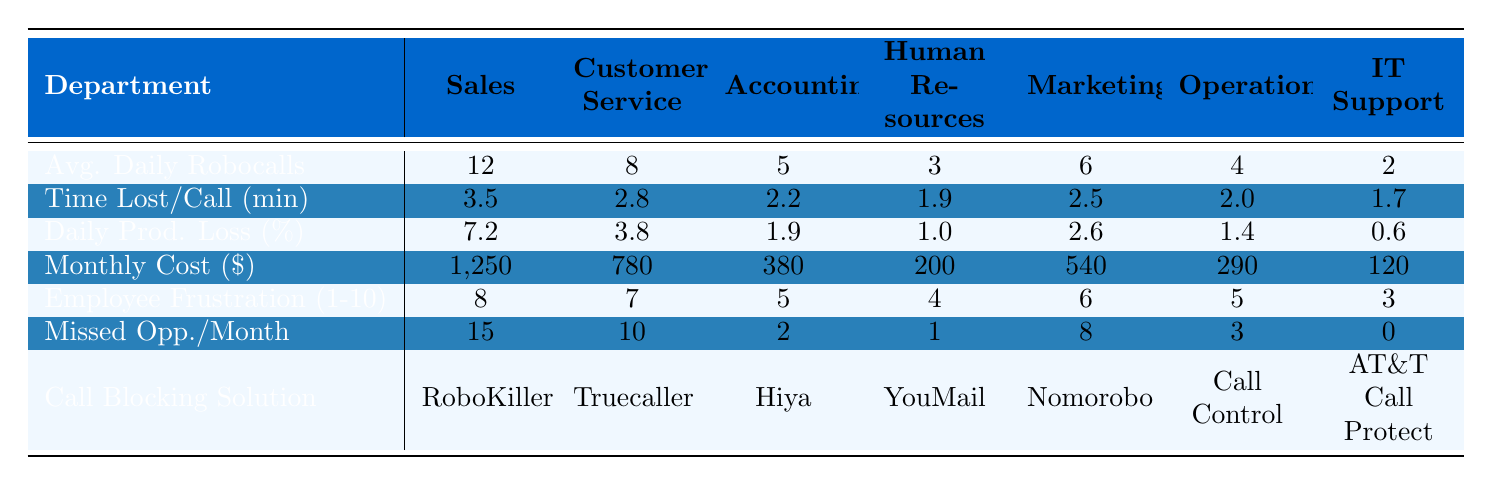What department experiences the highest average daily robocalls? Looking at the "Avg. Daily Robocalls" row, Sales department has the highest value of 12.
Answer: Sales What is the total daily productivity loss percentage for Sales and Customer Service? For Sales, the loss is 7.2% and for Customer Service, it's 3.8%. Adding these together gives 7.2 + 3.8 = 11%.
Answer: 11% Which department has the lowest employee frustration level? The "Employee Frustration (1-10)" row shows that IT Support has the lowest score of 3.
Answer: IT Support How much money is lost monthly due to productivity loss in the Accounting department? The "Monthly Cost" for Accounting is given as $380.
Answer: 380 Does Marketing have more missed opportunities per month than Human Resources? Marketing (8 missed opportunities) does indeed exceed Human Resources (1 missed opportunity).
Answer: Yes What is the average time lost per robocall across all departments? Summing the "Time Lost/Call (min)" gives (3.5 + 2.8 + 2.2 + 1.9 + 2.5 + 2.0 + 1.7) = 16.6 minutes, divided by 7 departments gives, on average, about 2.37 minutes.
Answer: 2.37 Which department implemented the most effective call-blocking solution based on missed opportunities? The department with fewest missed opportunities is IT Support (0 missed), indicating they have the most effective solution, which is AT&T Call Protect.
Answer: IT Support If the average daily robocalls for Human Resources doubled, what would be the new daily productivity loss percentage if other factors remain constant? Current daily robocalls for Human Resources is 3, doubling it would give 6. The time lost per call is 1.9 minutes. The new productivity loss percentage needs to be recalculated based on these new figures as it would affect the calculations significantly. Based on previous data, this could increase the loss to approximately double from 1.0% making it around 2% if the same percentage comparison is applied.
Answer: Approximately 2% What could be concluded about the relationship between employee frustration and missed opportunities? Looking at the data, higher employee frustration correlates to more missed opportunities in Sales (8 frustration, 15 missed) compared to IT Support (3 frustration, 0 missed). This trend could suggest a relationship where more frustration leads to more missed opportunities.
Answer: Frustration correlates with missed opportunities What is the average number of missed opportunities across all departments? Summing the missed opportunities gives (15 + 10 + 2 + 1 + 8 + 3 + 0) = 39 for 7 departments, dividing gives an average of about 5.57.
Answer: 5.57 